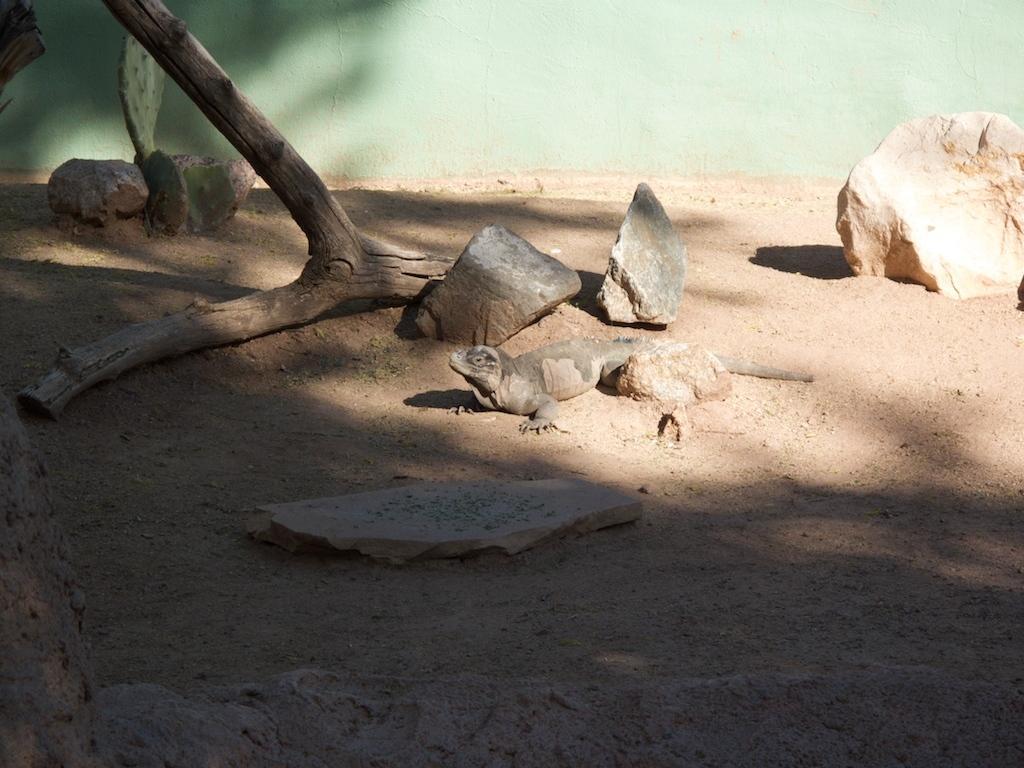Can you describe this image briefly? In this image we can see a reptile on the land. We can also see some stones, bark of a tree and a cactus plant. 